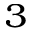Convert formula to latex. <formula><loc_0><loc_0><loc_500><loc_500>_ { 3 }</formula> 